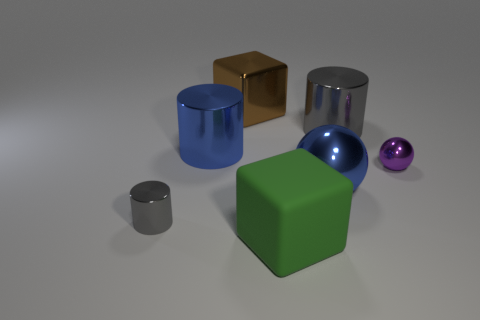Subtract all cyan spheres. How many gray cylinders are left? 2 Subtract all blue metallic cylinders. How many cylinders are left? 2 Add 3 tiny green metal balls. How many objects exist? 10 Subtract 1 cylinders. How many cylinders are left? 2 Subtract all cyan cylinders. Subtract all brown blocks. How many cylinders are left? 3 Subtract all spheres. How many objects are left? 5 Add 6 brown shiny cubes. How many brown shiny cubes are left? 7 Add 7 big blue cylinders. How many big blue cylinders exist? 8 Subtract 0 gray blocks. How many objects are left? 7 Subtract all big matte blocks. Subtract all tiny purple metal balls. How many objects are left? 5 